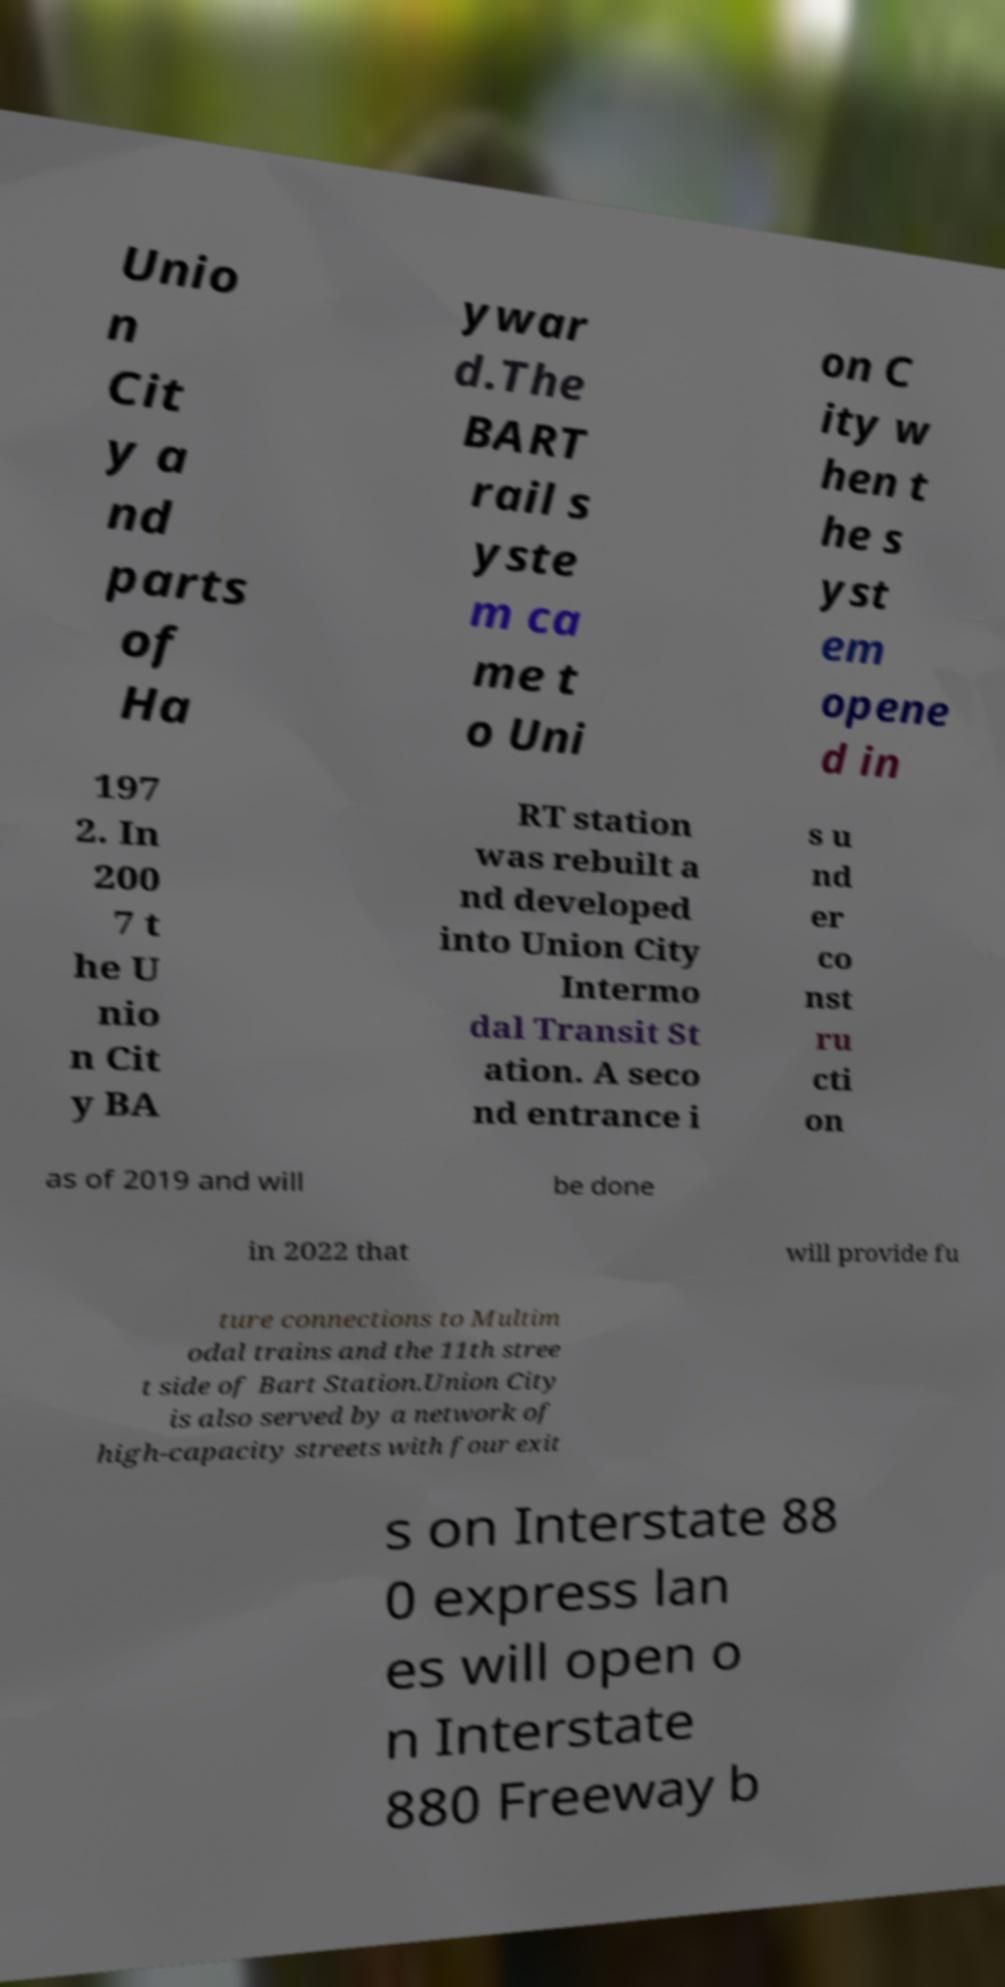Could you assist in decoding the text presented in this image and type it out clearly? Unio n Cit y a nd parts of Ha ywar d.The BART rail s yste m ca me t o Uni on C ity w hen t he s yst em opene d in 197 2. In 200 7 t he U nio n Cit y BA RT station was rebuilt a nd developed into Union City Intermo dal Transit St ation. A seco nd entrance i s u nd er co nst ru cti on as of 2019 and will be done in 2022 that will provide fu ture connections to Multim odal trains and the 11th stree t side of Bart Station.Union City is also served by a network of high-capacity streets with four exit s on Interstate 88 0 express lan es will open o n Interstate 880 Freeway b 